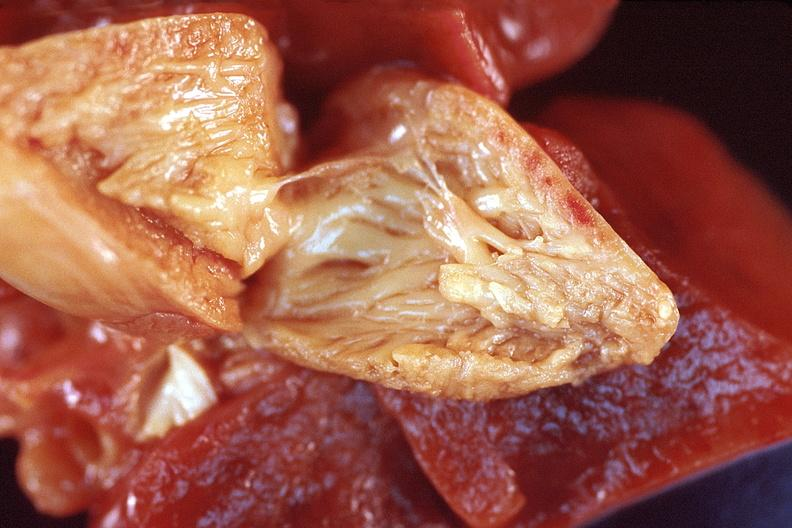what is present?
Answer the question using a single word or phrase. Cardiovascular 